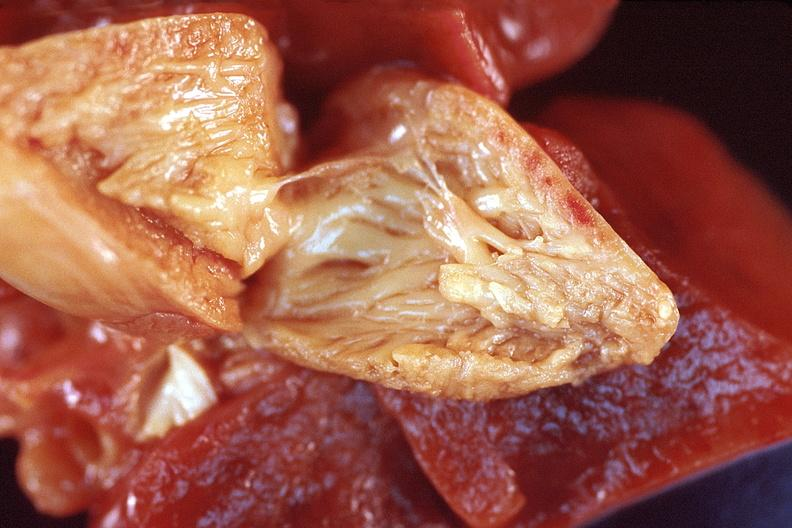what is present?
Answer the question using a single word or phrase. Cardiovascular 